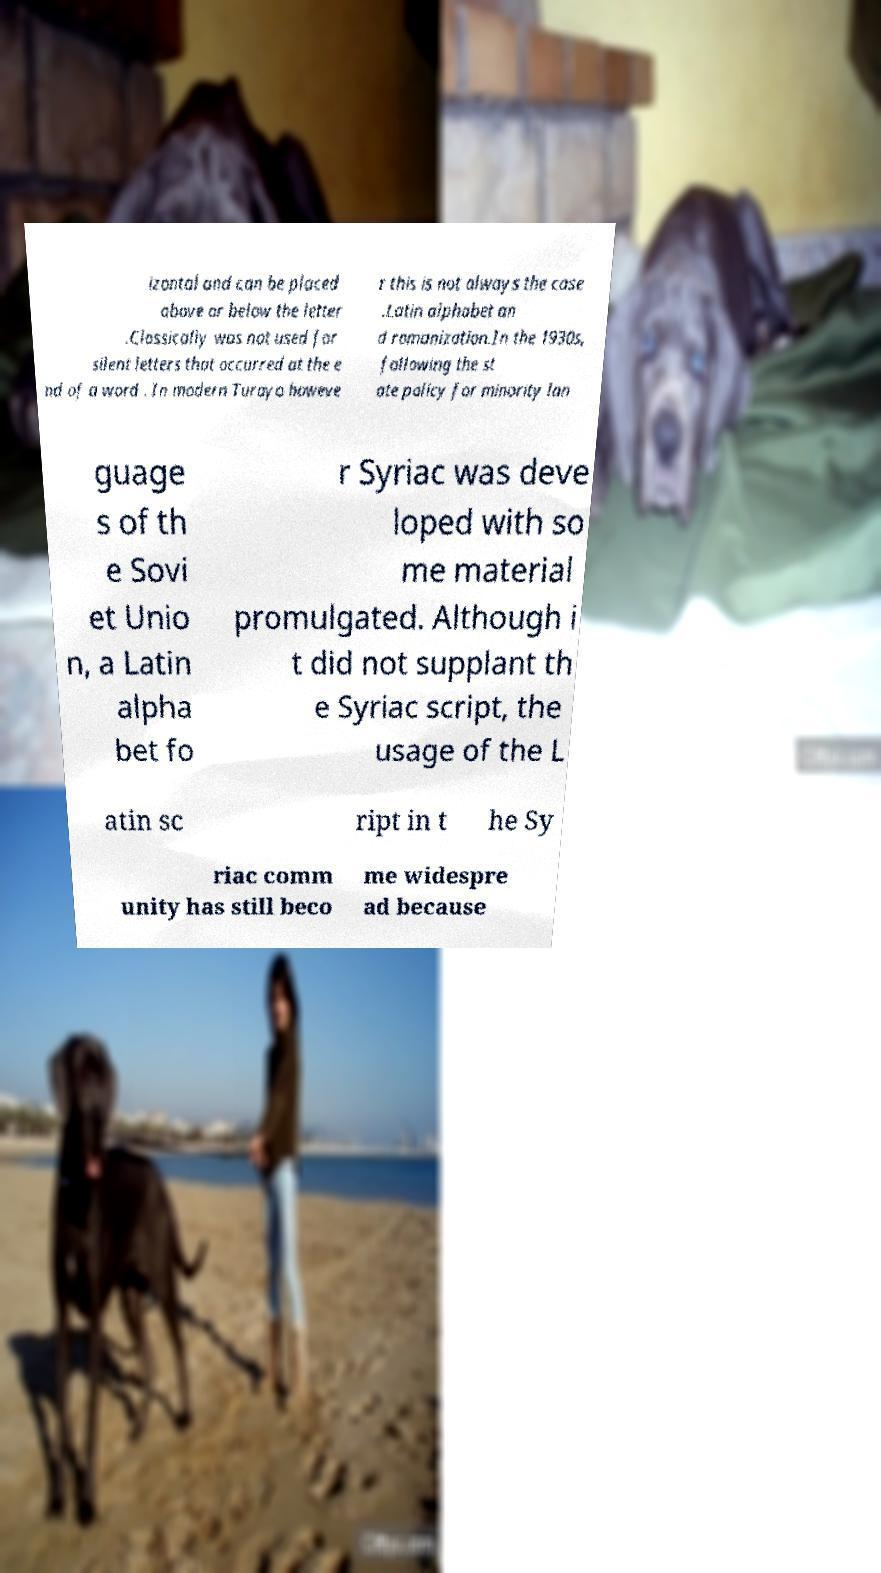I need the written content from this picture converted into text. Can you do that? izontal and can be placed above or below the letter .Classically was not used for silent letters that occurred at the e nd of a word . In modern Turoyo howeve r this is not always the case .Latin alphabet an d romanization.In the 1930s, following the st ate policy for minority lan guage s of th e Sovi et Unio n, a Latin alpha bet fo r Syriac was deve loped with so me material promulgated. Although i t did not supplant th e Syriac script, the usage of the L atin sc ript in t he Sy riac comm unity has still beco me widespre ad because 